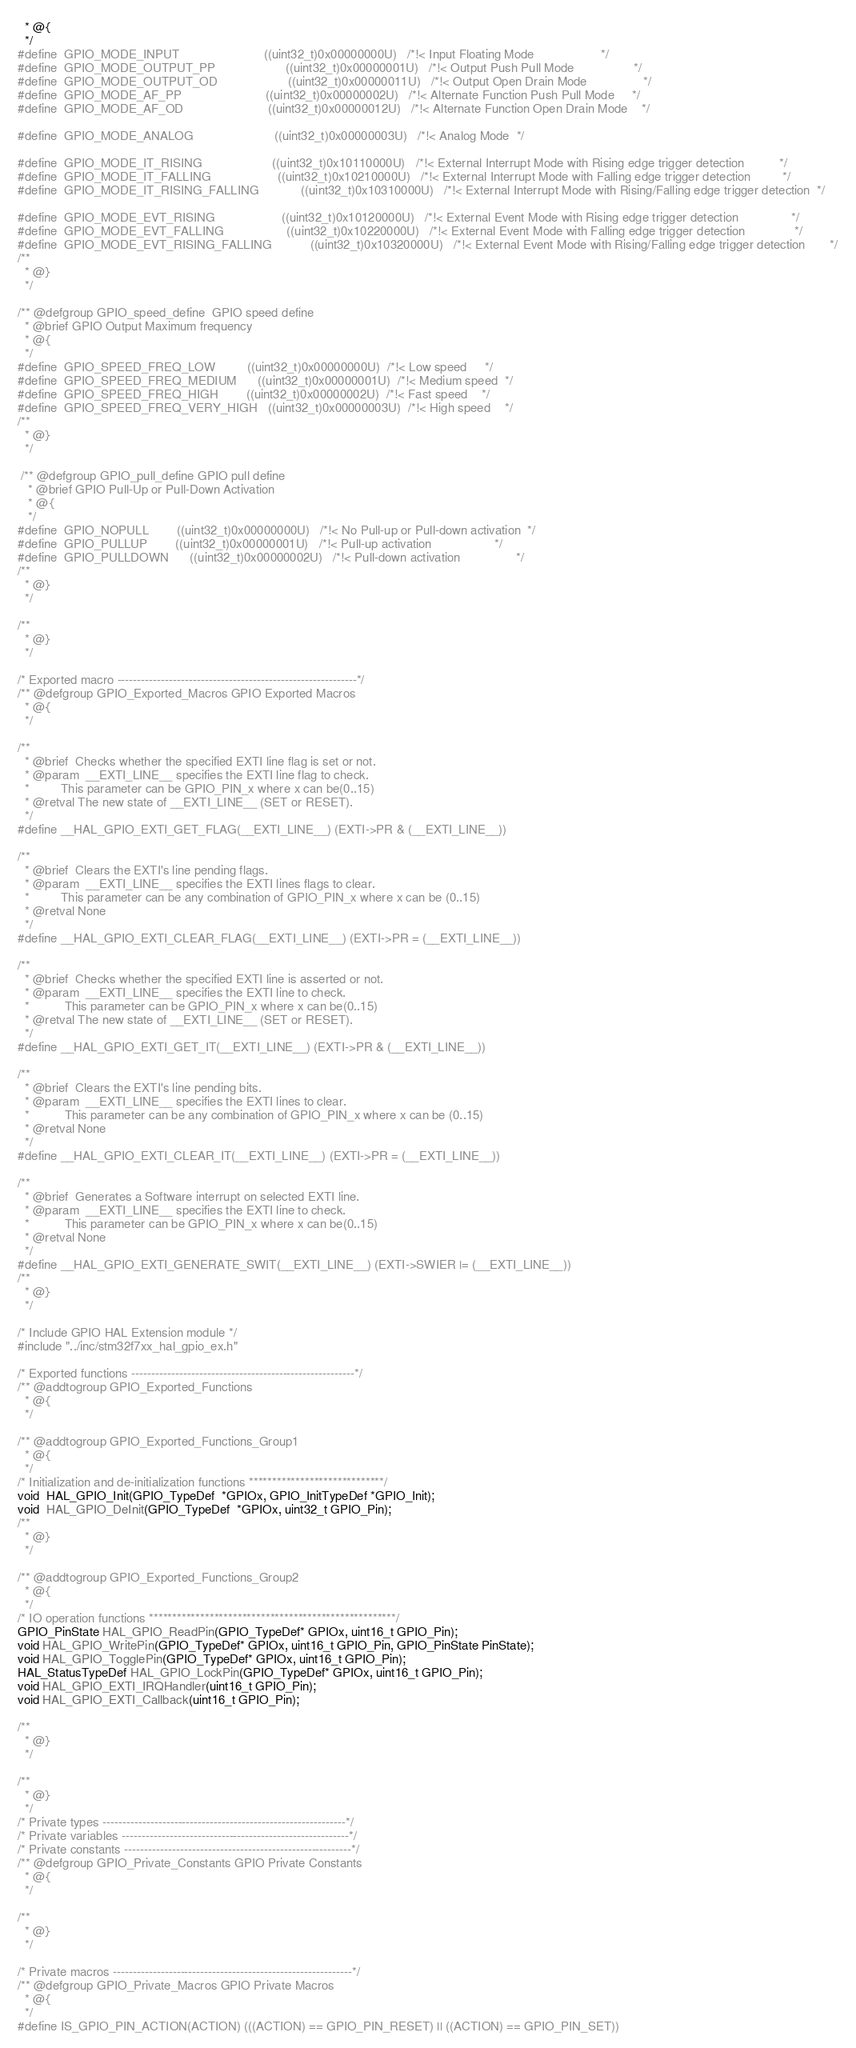Convert code to text. <code><loc_0><loc_0><loc_500><loc_500><_C_>  * @{
  */ 
#define  GPIO_MODE_INPUT                        ((uint32_t)0x00000000U)   /*!< Input Floating Mode                   */
#define  GPIO_MODE_OUTPUT_PP                    ((uint32_t)0x00000001U)   /*!< Output Push Pull Mode                 */
#define  GPIO_MODE_OUTPUT_OD                    ((uint32_t)0x00000011U)   /*!< Output Open Drain Mode                */
#define  GPIO_MODE_AF_PP                        ((uint32_t)0x00000002U)   /*!< Alternate Function Push Pull Mode     */
#define  GPIO_MODE_AF_OD                        ((uint32_t)0x00000012U)   /*!< Alternate Function Open Drain Mode    */

#define  GPIO_MODE_ANALOG                       ((uint32_t)0x00000003U)   /*!< Analog Mode  */
    
#define  GPIO_MODE_IT_RISING                    ((uint32_t)0x10110000U)   /*!< External Interrupt Mode with Rising edge trigger detection          */
#define  GPIO_MODE_IT_FALLING                   ((uint32_t)0x10210000U)   /*!< External Interrupt Mode with Falling edge trigger detection         */
#define  GPIO_MODE_IT_RISING_FALLING            ((uint32_t)0x10310000U)   /*!< External Interrupt Mode with Rising/Falling edge trigger detection  */
 
#define  GPIO_MODE_EVT_RISING                   ((uint32_t)0x10120000U)   /*!< External Event Mode with Rising edge trigger detection               */
#define  GPIO_MODE_EVT_FALLING                  ((uint32_t)0x10220000U)   /*!< External Event Mode with Falling edge trigger detection              */
#define  GPIO_MODE_EVT_RISING_FALLING           ((uint32_t)0x10320000U)   /*!< External Event Mode with Rising/Falling edge trigger detection       */
/**
  * @}
  */

/** @defgroup GPIO_speed_define  GPIO speed define
  * @brief GPIO Output Maximum frequency
  * @{
  */  
#define  GPIO_SPEED_FREQ_LOW         ((uint32_t)0x00000000U)  /*!< Low speed     */
#define  GPIO_SPEED_FREQ_MEDIUM      ((uint32_t)0x00000001U)  /*!< Medium speed  */
#define  GPIO_SPEED_FREQ_HIGH        ((uint32_t)0x00000002U)  /*!< Fast speed    */
#define  GPIO_SPEED_FREQ_VERY_HIGH   ((uint32_t)0x00000003U)  /*!< High speed    */
/**
  * @}
  */

 /** @defgroup GPIO_pull_define GPIO pull define
   * @brief GPIO Pull-Up or Pull-Down Activation
   * @{
   */  
#define  GPIO_NOPULL        ((uint32_t)0x00000000U)   /*!< No Pull-up or Pull-down activation  */
#define  GPIO_PULLUP        ((uint32_t)0x00000001U)   /*!< Pull-up activation                  */
#define  GPIO_PULLDOWN      ((uint32_t)0x00000002U)   /*!< Pull-down activation                */
/**
  * @}
  */
  
/**
  * @}
  */

/* Exported macro ------------------------------------------------------------*/
/** @defgroup GPIO_Exported_Macros GPIO Exported Macros
  * @{
  */

/**
  * @brief  Checks whether the specified EXTI line flag is set or not.
  * @param  __EXTI_LINE__ specifies the EXTI line flag to check.
  *         This parameter can be GPIO_PIN_x where x can be(0..15)
  * @retval The new state of __EXTI_LINE__ (SET or RESET).
  */
#define __HAL_GPIO_EXTI_GET_FLAG(__EXTI_LINE__) (EXTI->PR & (__EXTI_LINE__))

/**
  * @brief  Clears the EXTI's line pending flags.
  * @param  __EXTI_LINE__ specifies the EXTI lines flags to clear.
  *         This parameter can be any combination of GPIO_PIN_x where x can be (0..15)
  * @retval None
  */
#define __HAL_GPIO_EXTI_CLEAR_FLAG(__EXTI_LINE__) (EXTI->PR = (__EXTI_LINE__))

/**
  * @brief  Checks whether the specified EXTI line is asserted or not.
  * @param  __EXTI_LINE__ specifies the EXTI line to check.
  *          This parameter can be GPIO_PIN_x where x can be(0..15)
  * @retval The new state of __EXTI_LINE__ (SET or RESET).
  */
#define __HAL_GPIO_EXTI_GET_IT(__EXTI_LINE__) (EXTI->PR & (__EXTI_LINE__))

/**
  * @brief  Clears the EXTI's line pending bits.
  * @param  __EXTI_LINE__ specifies the EXTI lines to clear.
  *          This parameter can be any combination of GPIO_PIN_x where x can be (0..15)
  * @retval None
  */
#define __HAL_GPIO_EXTI_CLEAR_IT(__EXTI_LINE__) (EXTI->PR = (__EXTI_LINE__))

/**
  * @brief  Generates a Software interrupt on selected EXTI line.
  * @param  __EXTI_LINE__ specifies the EXTI line to check.
  *          This parameter can be GPIO_PIN_x where x can be(0..15)
  * @retval None
  */
#define __HAL_GPIO_EXTI_GENERATE_SWIT(__EXTI_LINE__) (EXTI->SWIER |= (__EXTI_LINE__))
/**
  * @}
  */

/* Include GPIO HAL Extension module */
#include "../inc/stm32f7xx_hal_gpio_ex.h"

/* Exported functions --------------------------------------------------------*/
/** @addtogroup GPIO_Exported_Functions
  * @{
  */

/** @addtogroup GPIO_Exported_Functions_Group1
  * @{
  */
/* Initialization and de-initialization functions *****************************/
void  HAL_GPIO_Init(GPIO_TypeDef  *GPIOx, GPIO_InitTypeDef *GPIO_Init);
void  HAL_GPIO_DeInit(GPIO_TypeDef  *GPIOx, uint32_t GPIO_Pin);
/**
  * @}
  */

/** @addtogroup GPIO_Exported_Functions_Group2
  * @{
  */
/* IO operation functions *****************************************************/
GPIO_PinState HAL_GPIO_ReadPin(GPIO_TypeDef* GPIOx, uint16_t GPIO_Pin);
void HAL_GPIO_WritePin(GPIO_TypeDef* GPIOx, uint16_t GPIO_Pin, GPIO_PinState PinState);
void HAL_GPIO_TogglePin(GPIO_TypeDef* GPIOx, uint16_t GPIO_Pin);
HAL_StatusTypeDef HAL_GPIO_LockPin(GPIO_TypeDef* GPIOx, uint16_t GPIO_Pin);
void HAL_GPIO_EXTI_IRQHandler(uint16_t GPIO_Pin);
void HAL_GPIO_EXTI_Callback(uint16_t GPIO_Pin);

/**
  * @}
  */ 

/**
  * @}
  */ 
/* Private types -------------------------------------------------------------*/
/* Private variables ---------------------------------------------------------*/
/* Private constants ---------------------------------------------------------*/
/** @defgroup GPIO_Private_Constants GPIO Private Constants
  * @{
  */

/**
  * @}
  */

/* Private macros ------------------------------------------------------------*/
/** @defgroup GPIO_Private_Macros GPIO Private Macros
  * @{
  */
#define IS_GPIO_PIN_ACTION(ACTION) (((ACTION) == GPIO_PIN_RESET) || ((ACTION) == GPIO_PIN_SET))</code> 